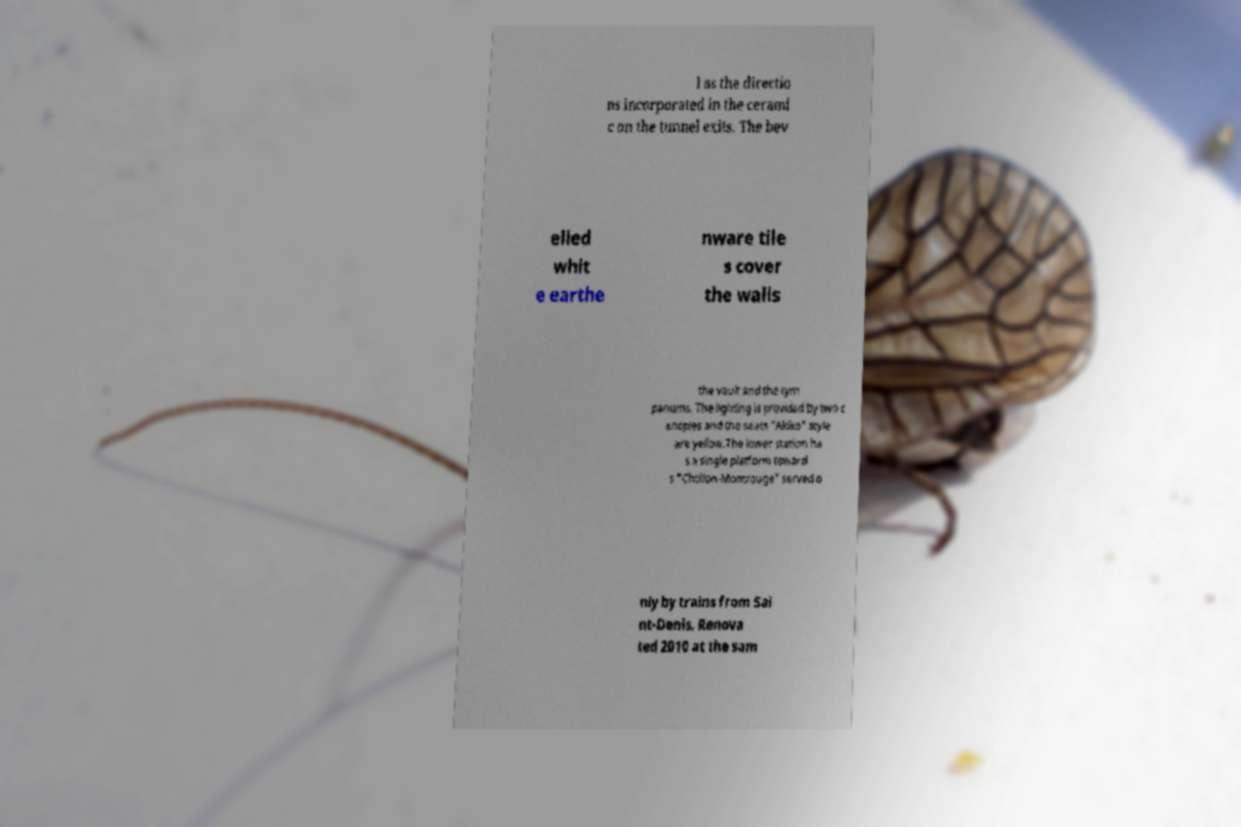Could you assist in decoding the text presented in this image and type it out clearly? l as the directio ns incorporated in the cerami c on the tunnel exits. The bev elled whit e earthe nware tile s cover the walls the vault and the tym panums. The lighting is provided by two c anopies and the seats "Akiko" style are yellow.The lower station ha s a single platform toward s "Chtillon-Montrouge" served o nly by trains from Sai nt-Denis. Renova ted 2010 at the sam 